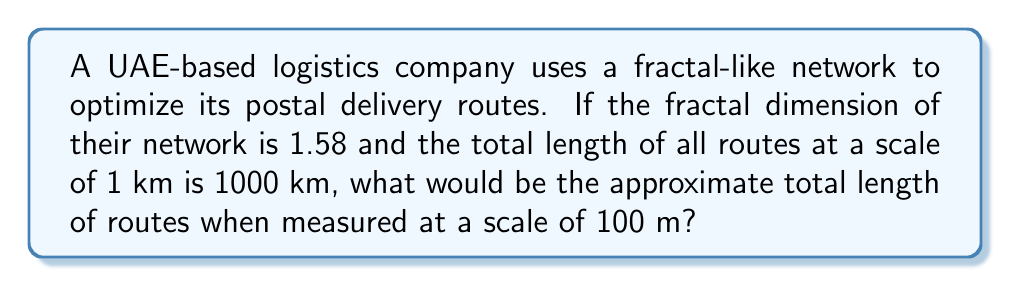Help me with this question. To solve this problem, we'll use the concept of fractal dimension and its relation to scale changes. The fractal dimension (D) describes how the detail of a pattern changes with the scale at which it is measured.

Step 1: Recall the fractal dimension formula:
$$ D = \frac{\log(N)}{\log(1/r)} $$
Where N is the number of self-similar pieces and r is the scale factor.

Step 2: In our case, we're changing the scale from 1 km to 100 m, so the scale factor r is:
$$ r = \frac{100 \text{ m}}{1000 \text{ m}} = 0.1 $$

Step 3: We can rearrange the fractal dimension formula to find N:
$$ N = (1/r)^D $$

Step 4: Substitute the known values:
$$ N = (1/0.1)^{1.58} = 10^{1.58} \approx 38.02 $$

Step 5: This means that for each kilometer of route at the 1 km scale, we'll have approximately 38.02 km of route at the 100 m scale.

Step 6: Calculate the total length at the new scale:
$$ \text{New Length} = 1000 \text{ km} \times 38.02 = 38,020 \text{ km} $$

Therefore, when measured at a scale of 100 m, the approximate total length of routes would be 38,020 km.
Answer: 38,020 km 